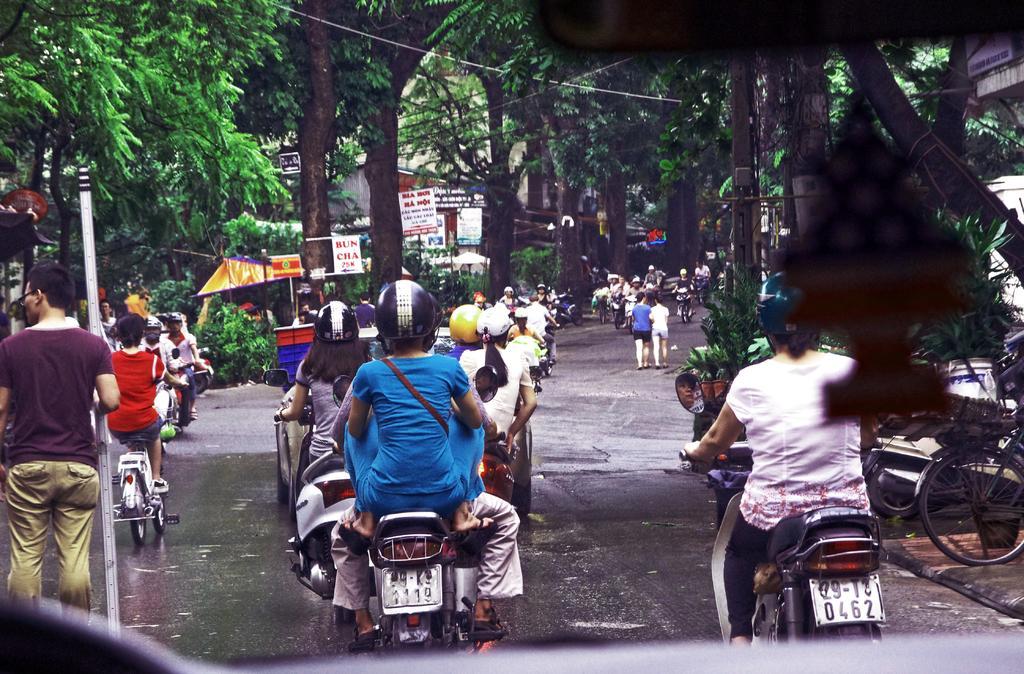Can you describe this image briefly? In the center of the image there are people driving on the road. In the background of the image there are trees. There is a building. To the left side of the image there is a person walking holding a object in his hand. 